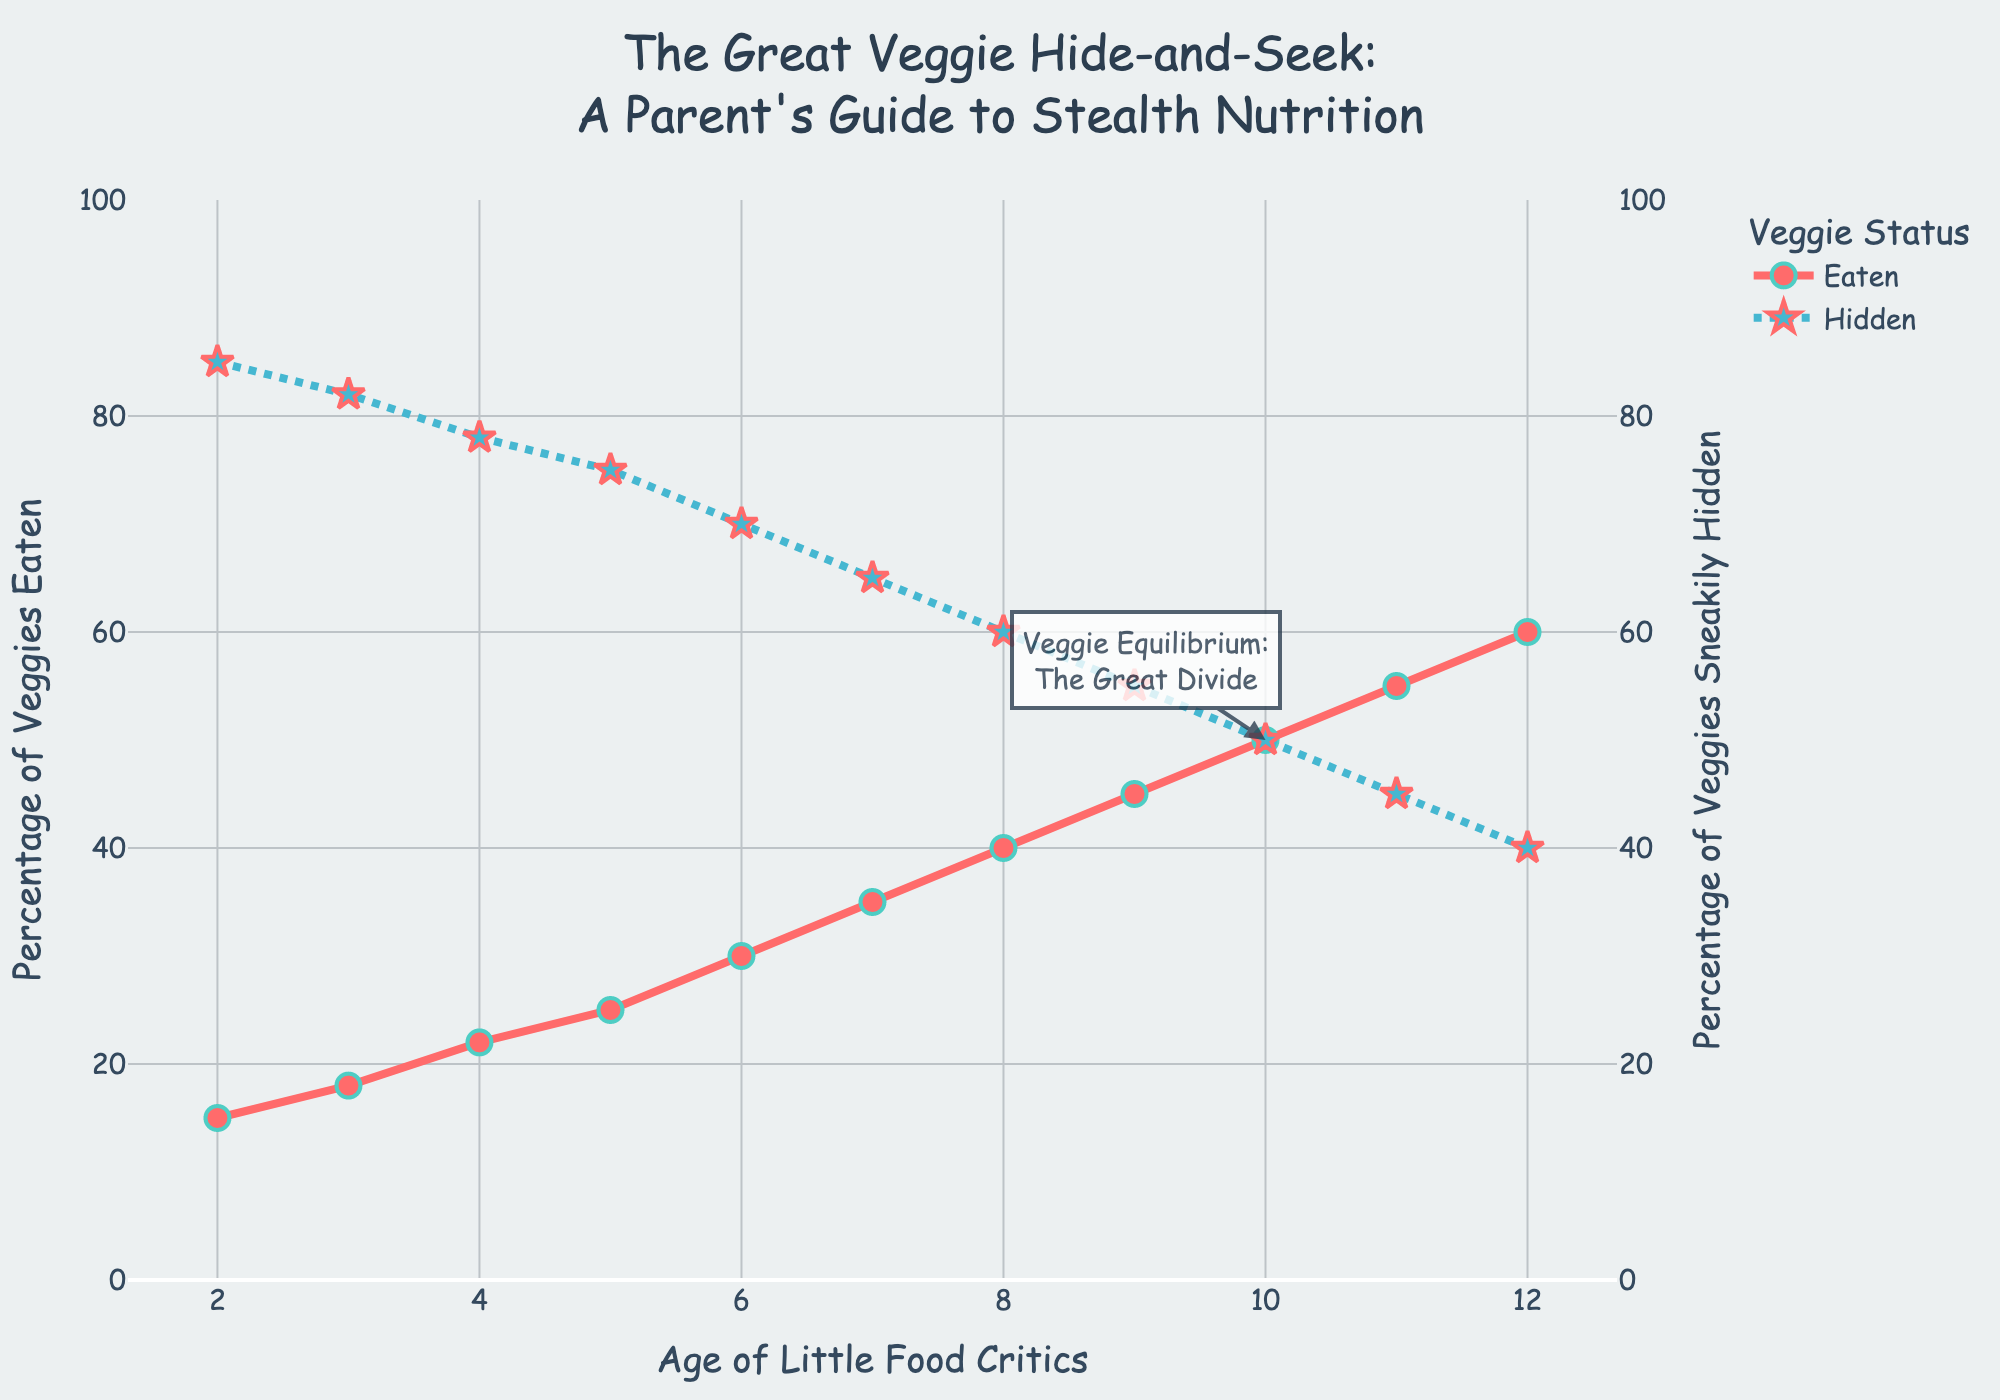What age has the highest percentage of vegetables eaten? By looking at the "Eaten" line, the highest value is at the far right of the plot which corresponds to age 12.
Answer: 12 At what age do children reach an equal percentage of vegetables eaten and hidden? According to the annotation labeled "Veggie Equilibrium: The Great Divide," this occurs when the "Eaten" and "Hidden" lines intersect, which is labeled at age 10.
Answer: 10 What is the average percentage of vegetables eaten by ages 2 to 12? To find the average, sum the percentages from ages 2 to 12 and divide by the number of ages. Sum = 15 + 18 + 22 + 25 + 30 + 35 + 40 + 45 + 50 + 55 + 60 = 395. There are 11 ages, so the average is 395 / 11 = 35.91.
Answer: 35.91 Compare the percentage change in veggies eaten from age 2 to age 8 and from age 8 to age 12. Which increase is higher? For age 2 to 8, the change is 40 - 15 = 25. For age 8 to 12, the change is 60 - 40 = 20. Therefore, the increase from age 2 to 8 is higher.
Answer: Age 2 to 8 Which line color indicates the percentage of hidden vegetables? The line for hidden vegetables is visually different with a dotted pattern and blue color.
Answer: Blue How many more percentage points of vegetables are eaten at age 6 compared to age 3? Using the "Eaten" line, at age 6, the percentage is 30 and at age 3, it's 18. Thus, 30 - 18 = 12 percentage points more are eaten at age 6.
Answer: 12 What is the sum percentage of hidden vegetables for ages 4 to 7? Sum the "Hidden" percentages for ages 4 through 7. Sum = 78 + 75 + 70 + 65 = 288.
Answer: 288 At what age do children start eating more than half of their vegetables? The "Eaten" line crosses above 50% after age 10, suggesting that it's at age 11 when the eaten percentage exceeds 50%.
Answer: 11 What is the difference in the percentage of hidden vegetables between ages 5 and 10? At age 5, the hidden percentage is 75, and at age 10, it is 50. The difference is 75 - 50 = 25.
Answer: 25 At what age is the percentage of hidden vegetables exactly 40%? According to the "Hidden" line, the percentage of hidden vegetables is exactly 40% at age 12.
Answer: 12 